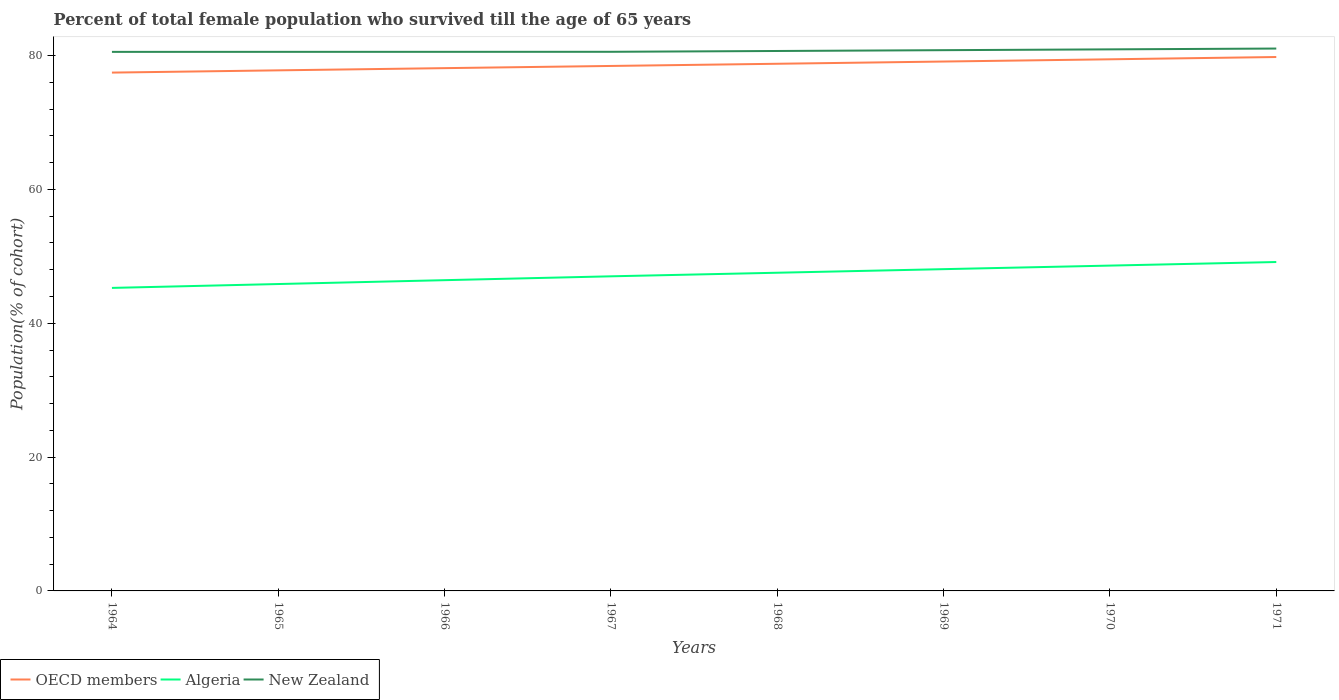Does the line corresponding to Algeria intersect with the line corresponding to OECD members?
Ensure brevity in your answer.  No. Is the number of lines equal to the number of legend labels?
Ensure brevity in your answer.  Yes. Across all years, what is the maximum percentage of total female population who survived till the age of 65 years in OECD members?
Your response must be concise. 77.46. In which year was the percentage of total female population who survived till the age of 65 years in New Zealand maximum?
Your answer should be very brief. 1964. What is the total percentage of total female population who survived till the age of 65 years in OECD members in the graph?
Your answer should be very brief. -1.66. What is the difference between the highest and the second highest percentage of total female population who survived till the age of 65 years in New Zealand?
Ensure brevity in your answer.  0.5. What is the difference between two consecutive major ticks on the Y-axis?
Your answer should be very brief. 20. Does the graph contain any zero values?
Your response must be concise. No. Where does the legend appear in the graph?
Offer a very short reply. Bottom left. How many legend labels are there?
Offer a terse response. 3. What is the title of the graph?
Provide a succinct answer. Percent of total female population who survived till the age of 65 years. Does "Germany" appear as one of the legend labels in the graph?
Ensure brevity in your answer.  No. What is the label or title of the Y-axis?
Offer a very short reply. Population(% of cohort). What is the Population(% of cohort) in OECD members in 1964?
Provide a succinct answer. 77.46. What is the Population(% of cohort) in Algeria in 1964?
Keep it short and to the point. 45.28. What is the Population(% of cohort) of New Zealand in 1964?
Give a very brief answer. 80.56. What is the Population(% of cohort) of OECD members in 1965?
Your answer should be very brief. 77.8. What is the Population(% of cohort) in Algeria in 1965?
Your answer should be compact. 45.86. What is the Population(% of cohort) of New Zealand in 1965?
Give a very brief answer. 80.56. What is the Population(% of cohort) in OECD members in 1966?
Provide a succinct answer. 78.13. What is the Population(% of cohort) in Algeria in 1966?
Offer a terse response. 46.44. What is the Population(% of cohort) in New Zealand in 1966?
Offer a very short reply. 80.56. What is the Population(% of cohort) of OECD members in 1967?
Keep it short and to the point. 78.45. What is the Population(% of cohort) of Algeria in 1967?
Your answer should be compact. 47.01. What is the Population(% of cohort) of New Zealand in 1967?
Your answer should be compact. 80.57. What is the Population(% of cohort) of OECD members in 1968?
Offer a very short reply. 78.78. What is the Population(% of cohort) in Algeria in 1968?
Make the answer very short. 47.55. What is the Population(% of cohort) of New Zealand in 1968?
Ensure brevity in your answer.  80.69. What is the Population(% of cohort) of OECD members in 1969?
Keep it short and to the point. 79.11. What is the Population(% of cohort) in Algeria in 1969?
Give a very brief answer. 48.08. What is the Population(% of cohort) in New Zealand in 1969?
Your answer should be compact. 80.81. What is the Population(% of cohort) in OECD members in 1970?
Your answer should be compact. 79.45. What is the Population(% of cohort) in Algeria in 1970?
Offer a terse response. 48.62. What is the Population(% of cohort) in New Zealand in 1970?
Keep it short and to the point. 80.93. What is the Population(% of cohort) of OECD members in 1971?
Provide a short and direct response. 79.79. What is the Population(% of cohort) of Algeria in 1971?
Your response must be concise. 49.15. What is the Population(% of cohort) of New Zealand in 1971?
Provide a succinct answer. 81.05. Across all years, what is the maximum Population(% of cohort) in OECD members?
Your response must be concise. 79.79. Across all years, what is the maximum Population(% of cohort) in Algeria?
Give a very brief answer. 49.15. Across all years, what is the maximum Population(% of cohort) in New Zealand?
Make the answer very short. 81.05. Across all years, what is the minimum Population(% of cohort) of OECD members?
Your answer should be compact. 77.46. Across all years, what is the minimum Population(% of cohort) in Algeria?
Provide a short and direct response. 45.28. Across all years, what is the minimum Population(% of cohort) in New Zealand?
Your answer should be very brief. 80.56. What is the total Population(% of cohort) in OECD members in the graph?
Provide a succinct answer. 628.96. What is the total Population(% of cohort) in Algeria in the graph?
Make the answer very short. 378. What is the total Population(% of cohort) of New Zealand in the graph?
Keep it short and to the point. 645.73. What is the difference between the Population(% of cohort) in OECD members in 1964 and that in 1965?
Your answer should be very brief. -0.34. What is the difference between the Population(% of cohort) of Algeria in 1964 and that in 1965?
Your answer should be very brief. -0.58. What is the difference between the Population(% of cohort) in New Zealand in 1964 and that in 1965?
Your answer should be very brief. -0. What is the difference between the Population(% of cohort) of OECD members in 1964 and that in 1966?
Keep it short and to the point. -0.67. What is the difference between the Population(% of cohort) in Algeria in 1964 and that in 1966?
Offer a terse response. -1.15. What is the difference between the Population(% of cohort) of New Zealand in 1964 and that in 1966?
Give a very brief answer. -0.01. What is the difference between the Population(% of cohort) in OECD members in 1964 and that in 1967?
Make the answer very short. -0.99. What is the difference between the Population(% of cohort) of Algeria in 1964 and that in 1967?
Give a very brief answer. -1.73. What is the difference between the Population(% of cohort) in New Zealand in 1964 and that in 1967?
Keep it short and to the point. -0.01. What is the difference between the Population(% of cohort) of OECD members in 1964 and that in 1968?
Ensure brevity in your answer.  -1.32. What is the difference between the Population(% of cohort) of Algeria in 1964 and that in 1968?
Offer a terse response. -2.27. What is the difference between the Population(% of cohort) in New Zealand in 1964 and that in 1968?
Keep it short and to the point. -0.13. What is the difference between the Population(% of cohort) of OECD members in 1964 and that in 1969?
Keep it short and to the point. -1.65. What is the difference between the Population(% of cohort) in Algeria in 1964 and that in 1969?
Provide a short and direct response. -2.8. What is the difference between the Population(% of cohort) of New Zealand in 1964 and that in 1969?
Provide a succinct answer. -0.25. What is the difference between the Population(% of cohort) in OECD members in 1964 and that in 1970?
Offer a very short reply. -1.99. What is the difference between the Population(% of cohort) of Algeria in 1964 and that in 1970?
Provide a succinct answer. -3.33. What is the difference between the Population(% of cohort) of New Zealand in 1964 and that in 1970?
Offer a terse response. -0.38. What is the difference between the Population(% of cohort) of OECD members in 1964 and that in 1971?
Keep it short and to the point. -2.33. What is the difference between the Population(% of cohort) of Algeria in 1964 and that in 1971?
Provide a succinct answer. -3.87. What is the difference between the Population(% of cohort) of New Zealand in 1964 and that in 1971?
Give a very brief answer. -0.5. What is the difference between the Population(% of cohort) of OECD members in 1965 and that in 1966?
Offer a terse response. -0.33. What is the difference between the Population(% of cohort) in Algeria in 1965 and that in 1966?
Your answer should be compact. -0.58. What is the difference between the Population(% of cohort) of New Zealand in 1965 and that in 1966?
Your answer should be compact. -0. What is the difference between the Population(% of cohort) of OECD members in 1965 and that in 1967?
Your answer should be compact. -0.66. What is the difference between the Population(% of cohort) of Algeria in 1965 and that in 1967?
Your answer should be compact. -1.15. What is the difference between the Population(% of cohort) of New Zealand in 1965 and that in 1967?
Your answer should be very brief. -0.01. What is the difference between the Population(% of cohort) in OECD members in 1965 and that in 1968?
Offer a very short reply. -0.98. What is the difference between the Population(% of cohort) in Algeria in 1965 and that in 1968?
Provide a short and direct response. -1.69. What is the difference between the Population(% of cohort) in New Zealand in 1965 and that in 1968?
Provide a succinct answer. -0.13. What is the difference between the Population(% of cohort) of OECD members in 1965 and that in 1969?
Make the answer very short. -1.32. What is the difference between the Population(% of cohort) of Algeria in 1965 and that in 1969?
Provide a short and direct response. -2.22. What is the difference between the Population(% of cohort) of New Zealand in 1965 and that in 1969?
Offer a very short reply. -0.25. What is the difference between the Population(% of cohort) in OECD members in 1965 and that in 1970?
Provide a short and direct response. -1.65. What is the difference between the Population(% of cohort) in Algeria in 1965 and that in 1970?
Give a very brief answer. -2.76. What is the difference between the Population(% of cohort) in New Zealand in 1965 and that in 1970?
Provide a short and direct response. -0.37. What is the difference between the Population(% of cohort) in OECD members in 1965 and that in 1971?
Your response must be concise. -1.99. What is the difference between the Population(% of cohort) in Algeria in 1965 and that in 1971?
Your answer should be compact. -3.29. What is the difference between the Population(% of cohort) in New Zealand in 1965 and that in 1971?
Keep it short and to the point. -0.49. What is the difference between the Population(% of cohort) of OECD members in 1966 and that in 1967?
Your response must be concise. -0.33. What is the difference between the Population(% of cohort) in Algeria in 1966 and that in 1967?
Offer a terse response. -0.58. What is the difference between the Population(% of cohort) of New Zealand in 1966 and that in 1967?
Your answer should be compact. -0. What is the difference between the Population(% of cohort) of OECD members in 1966 and that in 1968?
Your response must be concise. -0.65. What is the difference between the Population(% of cohort) of Algeria in 1966 and that in 1968?
Give a very brief answer. -1.11. What is the difference between the Population(% of cohort) in New Zealand in 1966 and that in 1968?
Your answer should be compact. -0.13. What is the difference between the Population(% of cohort) in OECD members in 1966 and that in 1969?
Make the answer very short. -0.99. What is the difference between the Population(% of cohort) in Algeria in 1966 and that in 1969?
Your answer should be compact. -1.65. What is the difference between the Population(% of cohort) in New Zealand in 1966 and that in 1969?
Your answer should be very brief. -0.25. What is the difference between the Population(% of cohort) of OECD members in 1966 and that in 1970?
Your response must be concise. -1.32. What is the difference between the Population(% of cohort) in Algeria in 1966 and that in 1970?
Ensure brevity in your answer.  -2.18. What is the difference between the Population(% of cohort) of New Zealand in 1966 and that in 1970?
Your answer should be very brief. -0.37. What is the difference between the Population(% of cohort) of OECD members in 1966 and that in 1971?
Ensure brevity in your answer.  -1.66. What is the difference between the Population(% of cohort) of Algeria in 1966 and that in 1971?
Offer a very short reply. -2.71. What is the difference between the Population(% of cohort) of New Zealand in 1966 and that in 1971?
Your answer should be very brief. -0.49. What is the difference between the Population(% of cohort) of OECD members in 1967 and that in 1968?
Give a very brief answer. -0.33. What is the difference between the Population(% of cohort) in Algeria in 1967 and that in 1968?
Your response must be concise. -0.53. What is the difference between the Population(% of cohort) in New Zealand in 1967 and that in 1968?
Your answer should be compact. -0.12. What is the difference between the Population(% of cohort) of OECD members in 1967 and that in 1969?
Provide a short and direct response. -0.66. What is the difference between the Population(% of cohort) in Algeria in 1967 and that in 1969?
Your answer should be very brief. -1.07. What is the difference between the Population(% of cohort) of New Zealand in 1967 and that in 1969?
Give a very brief answer. -0.24. What is the difference between the Population(% of cohort) of OECD members in 1967 and that in 1970?
Ensure brevity in your answer.  -0.99. What is the difference between the Population(% of cohort) of Algeria in 1967 and that in 1970?
Your response must be concise. -1.6. What is the difference between the Population(% of cohort) in New Zealand in 1967 and that in 1970?
Make the answer very short. -0.37. What is the difference between the Population(% of cohort) of OECD members in 1967 and that in 1971?
Offer a terse response. -1.33. What is the difference between the Population(% of cohort) of Algeria in 1967 and that in 1971?
Your answer should be very brief. -2.14. What is the difference between the Population(% of cohort) of New Zealand in 1967 and that in 1971?
Your response must be concise. -0.49. What is the difference between the Population(% of cohort) in OECD members in 1968 and that in 1969?
Make the answer very short. -0.33. What is the difference between the Population(% of cohort) of Algeria in 1968 and that in 1969?
Ensure brevity in your answer.  -0.53. What is the difference between the Population(% of cohort) of New Zealand in 1968 and that in 1969?
Give a very brief answer. -0.12. What is the difference between the Population(% of cohort) in OECD members in 1968 and that in 1970?
Provide a succinct answer. -0.67. What is the difference between the Population(% of cohort) in Algeria in 1968 and that in 1970?
Ensure brevity in your answer.  -1.07. What is the difference between the Population(% of cohort) of New Zealand in 1968 and that in 1970?
Your answer should be compact. -0.24. What is the difference between the Population(% of cohort) in OECD members in 1968 and that in 1971?
Keep it short and to the point. -1.01. What is the difference between the Population(% of cohort) in Algeria in 1968 and that in 1971?
Provide a succinct answer. -1.6. What is the difference between the Population(% of cohort) in New Zealand in 1968 and that in 1971?
Your answer should be compact. -0.37. What is the difference between the Population(% of cohort) in OECD members in 1969 and that in 1970?
Provide a short and direct response. -0.33. What is the difference between the Population(% of cohort) of Algeria in 1969 and that in 1970?
Make the answer very short. -0.53. What is the difference between the Population(% of cohort) in New Zealand in 1969 and that in 1970?
Give a very brief answer. -0.12. What is the difference between the Population(% of cohort) of OECD members in 1969 and that in 1971?
Offer a terse response. -0.67. What is the difference between the Population(% of cohort) in Algeria in 1969 and that in 1971?
Your response must be concise. -1.07. What is the difference between the Population(% of cohort) in New Zealand in 1969 and that in 1971?
Provide a succinct answer. -0.24. What is the difference between the Population(% of cohort) in OECD members in 1970 and that in 1971?
Give a very brief answer. -0.34. What is the difference between the Population(% of cohort) in Algeria in 1970 and that in 1971?
Make the answer very short. -0.53. What is the difference between the Population(% of cohort) in New Zealand in 1970 and that in 1971?
Keep it short and to the point. -0.12. What is the difference between the Population(% of cohort) in OECD members in 1964 and the Population(% of cohort) in Algeria in 1965?
Offer a very short reply. 31.6. What is the difference between the Population(% of cohort) of OECD members in 1964 and the Population(% of cohort) of New Zealand in 1965?
Keep it short and to the point. -3.1. What is the difference between the Population(% of cohort) in Algeria in 1964 and the Population(% of cohort) in New Zealand in 1965?
Offer a very short reply. -35.28. What is the difference between the Population(% of cohort) of OECD members in 1964 and the Population(% of cohort) of Algeria in 1966?
Give a very brief answer. 31.02. What is the difference between the Population(% of cohort) of OECD members in 1964 and the Population(% of cohort) of New Zealand in 1966?
Your answer should be compact. -3.1. What is the difference between the Population(% of cohort) of Algeria in 1964 and the Population(% of cohort) of New Zealand in 1966?
Provide a short and direct response. -35.28. What is the difference between the Population(% of cohort) in OECD members in 1964 and the Population(% of cohort) in Algeria in 1967?
Your answer should be compact. 30.44. What is the difference between the Population(% of cohort) of OECD members in 1964 and the Population(% of cohort) of New Zealand in 1967?
Provide a succinct answer. -3.11. What is the difference between the Population(% of cohort) of Algeria in 1964 and the Population(% of cohort) of New Zealand in 1967?
Make the answer very short. -35.28. What is the difference between the Population(% of cohort) in OECD members in 1964 and the Population(% of cohort) in Algeria in 1968?
Your response must be concise. 29.91. What is the difference between the Population(% of cohort) in OECD members in 1964 and the Population(% of cohort) in New Zealand in 1968?
Your answer should be compact. -3.23. What is the difference between the Population(% of cohort) of Algeria in 1964 and the Population(% of cohort) of New Zealand in 1968?
Your response must be concise. -35.4. What is the difference between the Population(% of cohort) of OECD members in 1964 and the Population(% of cohort) of Algeria in 1969?
Offer a very short reply. 29.37. What is the difference between the Population(% of cohort) of OECD members in 1964 and the Population(% of cohort) of New Zealand in 1969?
Offer a very short reply. -3.35. What is the difference between the Population(% of cohort) of Algeria in 1964 and the Population(% of cohort) of New Zealand in 1969?
Ensure brevity in your answer.  -35.53. What is the difference between the Population(% of cohort) in OECD members in 1964 and the Population(% of cohort) in Algeria in 1970?
Keep it short and to the point. 28.84. What is the difference between the Population(% of cohort) in OECD members in 1964 and the Population(% of cohort) in New Zealand in 1970?
Keep it short and to the point. -3.47. What is the difference between the Population(% of cohort) of Algeria in 1964 and the Population(% of cohort) of New Zealand in 1970?
Offer a terse response. -35.65. What is the difference between the Population(% of cohort) of OECD members in 1964 and the Population(% of cohort) of Algeria in 1971?
Keep it short and to the point. 28.31. What is the difference between the Population(% of cohort) of OECD members in 1964 and the Population(% of cohort) of New Zealand in 1971?
Provide a short and direct response. -3.6. What is the difference between the Population(% of cohort) of Algeria in 1964 and the Population(% of cohort) of New Zealand in 1971?
Your answer should be very brief. -35.77. What is the difference between the Population(% of cohort) in OECD members in 1965 and the Population(% of cohort) in Algeria in 1966?
Your response must be concise. 31.36. What is the difference between the Population(% of cohort) of OECD members in 1965 and the Population(% of cohort) of New Zealand in 1966?
Provide a succinct answer. -2.77. What is the difference between the Population(% of cohort) of Algeria in 1965 and the Population(% of cohort) of New Zealand in 1966?
Provide a succinct answer. -34.7. What is the difference between the Population(% of cohort) in OECD members in 1965 and the Population(% of cohort) in Algeria in 1967?
Your answer should be very brief. 30.78. What is the difference between the Population(% of cohort) of OECD members in 1965 and the Population(% of cohort) of New Zealand in 1967?
Keep it short and to the point. -2.77. What is the difference between the Population(% of cohort) of Algeria in 1965 and the Population(% of cohort) of New Zealand in 1967?
Offer a very short reply. -34.71. What is the difference between the Population(% of cohort) in OECD members in 1965 and the Population(% of cohort) in Algeria in 1968?
Make the answer very short. 30.25. What is the difference between the Population(% of cohort) in OECD members in 1965 and the Population(% of cohort) in New Zealand in 1968?
Keep it short and to the point. -2.89. What is the difference between the Population(% of cohort) in Algeria in 1965 and the Population(% of cohort) in New Zealand in 1968?
Make the answer very short. -34.83. What is the difference between the Population(% of cohort) in OECD members in 1965 and the Population(% of cohort) in Algeria in 1969?
Your answer should be compact. 29.71. What is the difference between the Population(% of cohort) in OECD members in 1965 and the Population(% of cohort) in New Zealand in 1969?
Give a very brief answer. -3.01. What is the difference between the Population(% of cohort) of Algeria in 1965 and the Population(% of cohort) of New Zealand in 1969?
Ensure brevity in your answer.  -34.95. What is the difference between the Population(% of cohort) in OECD members in 1965 and the Population(% of cohort) in Algeria in 1970?
Give a very brief answer. 29.18. What is the difference between the Population(% of cohort) in OECD members in 1965 and the Population(% of cohort) in New Zealand in 1970?
Offer a very short reply. -3.14. What is the difference between the Population(% of cohort) of Algeria in 1965 and the Population(% of cohort) of New Zealand in 1970?
Provide a succinct answer. -35.07. What is the difference between the Population(% of cohort) in OECD members in 1965 and the Population(% of cohort) in Algeria in 1971?
Give a very brief answer. 28.64. What is the difference between the Population(% of cohort) in OECD members in 1965 and the Population(% of cohort) in New Zealand in 1971?
Make the answer very short. -3.26. What is the difference between the Population(% of cohort) in Algeria in 1965 and the Population(% of cohort) in New Zealand in 1971?
Your answer should be very brief. -35.19. What is the difference between the Population(% of cohort) of OECD members in 1966 and the Population(% of cohort) of Algeria in 1967?
Your response must be concise. 31.11. What is the difference between the Population(% of cohort) in OECD members in 1966 and the Population(% of cohort) in New Zealand in 1967?
Keep it short and to the point. -2.44. What is the difference between the Population(% of cohort) in Algeria in 1966 and the Population(% of cohort) in New Zealand in 1967?
Offer a terse response. -34.13. What is the difference between the Population(% of cohort) of OECD members in 1966 and the Population(% of cohort) of Algeria in 1968?
Give a very brief answer. 30.58. What is the difference between the Population(% of cohort) of OECD members in 1966 and the Population(% of cohort) of New Zealand in 1968?
Offer a very short reply. -2.56. What is the difference between the Population(% of cohort) of Algeria in 1966 and the Population(% of cohort) of New Zealand in 1968?
Your answer should be compact. -34.25. What is the difference between the Population(% of cohort) in OECD members in 1966 and the Population(% of cohort) in Algeria in 1969?
Keep it short and to the point. 30.04. What is the difference between the Population(% of cohort) in OECD members in 1966 and the Population(% of cohort) in New Zealand in 1969?
Your response must be concise. -2.68. What is the difference between the Population(% of cohort) of Algeria in 1966 and the Population(% of cohort) of New Zealand in 1969?
Offer a terse response. -34.37. What is the difference between the Population(% of cohort) in OECD members in 1966 and the Population(% of cohort) in Algeria in 1970?
Provide a succinct answer. 29.51. What is the difference between the Population(% of cohort) in OECD members in 1966 and the Population(% of cohort) in New Zealand in 1970?
Offer a terse response. -2.81. What is the difference between the Population(% of cohort) in Algeria in 1966 and the Population(% of cohort) in New Zealand in 1970?
Offer a terse response. -34.49. What is the difference between the Population(% of cohort) in OECD members in 1966 and the Population(% of cohort) in Algeria in 1971?
Provide a succinct answer. 28.97. What is the difference between the Population(% of cohort) in OECD members in 1966 and the Population(% of cohort) in New Zealand in 1971?
Your answer should be very brief. -2.93. What is the difference between the Population(% of cohort) of Algeria in 1966 and the Population(% of cohort) of New Zealand in 1971?
Provide a short and direct response. -34.62. What is the difference between the Population(% of cohort) in OECD members in 1967 and the Population(% of cohort) in Algeria in 1968?
Your answer should be very brief. 30.9. What is the difference between the Population(% of cohort) of OECD members in 1967 and the Population(% of cohort) of New Zealand in 1968?
Ensure brevity in your answer.  -2.24. What is the difference between the Population(% of cohort) in Algeria in 1967 and the Population(% of cohort) in New Zealand in 1968?
Provide a short and direct response. -33.67. What is the difference between the Population(% of cohort) in OECD members in 1967 and the Population(% of cohort) in Algeria in 1969?
Provide a short and direct response. 30.37. What is the difference between the Population(% of cohort) in OECD members in 1967 and the Population(% of cohort) in New Zealand in 1969?
Provide a succinct answer. -2.36. What is the difference between the Population(% of cohort) of Algeria in 1967 and the Population(% of cohort) of New Zealand in 1969?
Your answer should be very brief. -33.8. What is the difference between the Population(% of cohort) in OECD members in 1967 and the Population(% of cohort) in Algeria in 1970?
Give a very brief answer. 29.83. What is the difference between the Population(% of cohort) in OECD members in 1967 and the Population(% of cohort) in New Zealand in 1970?
Ensure brevity in your answer.  -2.48. What is the difference between the Population(% of cohort) in Algeria in 1967 and the Population(% of cohort) in New Zealand in 1970?
Offer a very short reply. -33.92. What is the difference between the Population(% of cohort) of OECD members in 1967 and the Population(% of cohort) of Algeria in 1971?
Give a very brief answer. 29.3. What is the difference between the Population(% of cohort) of OECD members in 1967 and the Population(% of cohort) of New Zealand in 1971?
Give a very brief answer. -2.6. What is the difference between the Population(% of cohort) in Algeria in 1967 and the Population(% of cohort) in New Zealand in 1971?
Keep it short and to the point. -34.04. What is the difference between the Population(% of cohort) in OECD members in 1968 and the Population(% of cohort) in Algeria in 1969?
Provide a succinct answer. 30.69. What is the difference between the Population(% of cohort) of OECD members in 1968 and the Population(% of cohort) of New Zealand in 1969?
Your answer should be compact. -2.03. What is the difference between the Population(% of cohort) in Algeria in 1968 and the Population(% of cohort) in New Zealand in 1969?
Your response must be concise. -33.26. What is the difference between the Population(% of cohort) in OECD members in 1968 and the Population(% of cohort) in Algeria in 1970?
Give a very brief answer. 30.16. What is the difference between the Population(% of cohort) in OECD members in 1968 and the Population(% of cohort) in New Zealand in 1970?
Give a very brief answer. -2.15. What is the difference between the Population(% of cohort) of Algeria in 1968 and the Population(% of cohort) of New Zealand in 1970?
Your answer should be compact. -33.38. What is the difference between the Population(% of cohort) of OECD members in 1968 and the Population(% of cohort) of Algeria in 1971?
Make the answer very short. 29.63. What is the difference between the Population(% of cohort) of OECD members in 1968 and the Population(% of cohort) of New Zealand in 1971?
Offer a very short reply. -2.28. What is the difference between the Population(% of cohort) of Algeria in 1968 and the Population(% of cohort) of New Zealand in 1971?
Provide a succinct answer. -33.5. What is the difference between the Population(% of cohort) of OECD members in 1969 and the Population(% of cohort) of Algeria in 1970?
Provide a succinct answer. 30.49. What is the difference between the Population(% of cohort) in OECD members in 1969 and the Population(% of cohort) in New Zealand in 1970?
Provide a short and direct response. -1.82. What is the difference between the Population(% of cohort) of Algeria in 1969 and the Population(% of cohort) of New Zealand in 1970?
Make the answer very short. -32.85. What is the difference between the Population(% of cohort) of OECD members in 1969 and the Population(% of cohort) of Algeria in 1971?
Your answer should be very brief. 29.96. What is the difference between the Population(% of cohort) in OECD members in 1969 and the Population(% of cohort) in New Zealand in 1971?
Offer a very short reply. -1.94. What is the difference between the Population(% of cohort) in Algeria in 1969 and the Population(% of cohort) in New Zealand in 1971?
Offer a very short reply. -32.97. What is the difference between the Population(% of cohort) of OECD members in 1970 and the Population(% of cohort) of Algeria in 1971?
Make the answer very short. 30.29. What is the difference between the Population(% of cohort) in OECD members in 1970 and the Population(% of cohort) in New Zealand in 1971?
Provide a short and direct response. -1.61. What is the difference between the Population(% of cohort) in Algeria in 1970 and the Population(% of cohort) in New Zealand in 1971?
Your answer should be compact. -32.44. What is the average Population(% of cohort) of OECD members per year?
Provide a succinct answer. 78.62. What is the average Population(% of cohort) of Algeria per year?
Keep it short and to the point. 47.25. What is the average Population(% of cohort) of New Zealand per year?
Offer a very short reply. 80.72. In the year 1964, what is the difference between the Population(% of cohort) of OECD members and Population(% of cohort) of Algeria?
Give a very brief answer. 32.17. In the year 1964, what is the difference between the Population(% of cohort) of OECD members and Population(% of cohort) of New Zealand?
Your answer should be compact. -3.1. In the year 1964, what is the difference between the Population(% of cohort) of Algeria and Population(% of cohort) of New Zealand?
Provide a short and direct response. -35.27. In the year 1965, what is the difference between the Population(% of cohort) of OECD members and Population(% of cohort) of Algeria?
Offer a very short reply. 31.94. In the year 1965, what is the difference between the Population(% of cohort) of OECD members and Population(% of cohort) of New Zealand?
Offer a very short reply. -2.76. In the year 1965, what is the difference between the Population(% of cohort) of Algeria and Population(% of cohort) of New Zealand?
Keep it short and to the point. -34.7. In the year 1966, what is the difference between the Population(% of cohort) of OECD members and Population(% of cohort) of Algeria?
Provide a short and direct response. 31.69. In the year 1966, what is the difference between the Population(% of cohort) in OECD members and Population(% of cohort) in New Zealand?
Make the answer very short. -2.44. In the year 1966, what is the difference between the Population(% of cohort) of Algeria and Population(% of cohort) of New Zealand?
Give a very brief answer. -34.12. In the year 1967, what is the difference between the Population(% of cohort) of OECD members and Population(% of cohort) of Algeria?
Make the answer very short. 31.44. In the year 1967, what is the difference between the Population(% of cohort) of OECD members and Population(% of cohort) of New Zealand?
Keep it short and to the point. -2.11. In the year 1967, what is the difference between the Population(% of cohort) in Algeria and Population(% of cohort) in New Zealand?
Your answer should be very brief. -33.55. In the year 1968, what is the difference between the Population(% of cohort) of OECD members and Population(% of cohort) of Algeria?
Your answer should be compact. 31.23. In the year 1968, what is the difference between the Population(% of cohort) of OECD members and Population(% of cohort) of New Zealand?
Provide a succinct answer. -1.91. In the year 1968, what is the difference between the Population(% of cohort) of Algeria and Population(% of cohort) of New Zealand?
Give a very brief answer. -33.14. In the year 1969, what is the difference between the Population(% of cohort) of OECD members and Population(% of cohort) of Algeria?
Your response must be concise. 31.03. In the year 1969, what is the difference between the Population(% of cohort) in OECD members and Population(% of cohort) in New Zealand?
Make the answer very short. -1.7. In the year 1969, what is the difference between the Population(% of cohort) in Algeria and Population(% of cohort) in New Zealand?
Offer a very short reply. -32.73. In the year 1970, what is the difference between the Population(% of cohort) in OECD members and Population(% of cohort) in Algeria?
Provide a succinct answer. 30.83. In the year 1970, what is the difference between the Population(% of cohort) of OECD members and Population(% of cohort) of New Zealand?
Your response must be concise. -1.49. In the year 1970, what is the difference between the Population(% of cohort) in Algeria and Population(% of cohort) in New Zealand?
Offer a very short reply. -32.31. In the year 1971, what is the difference between the Population(% of cohort) of OECD members and Population(% of cohort) of Algeria?
Provide a succinct answer. 30.63. In the year 1971, what is the difference between the Population(% of cohort) of OECD members and Population(% of cohort) of New Zealand?
Ensure brevity in your answer.  -1.27. In the year 1971, what is the difference between the Population(% of cohort) of Algeria and Population(% of cohort) of New Zealand?
Offer a very short reply. -31.9. What is the ratio of the Population(% of cohort) of Algeria in 1964 to that in 1965?
Your response must be concise. 0.99. What is the ratio of the Population(% of cohort) in Algeria in 1964 to that in 1966?
Your answer should be very brief. 0.98. What is the ratio of the Population(% of cohort) in New Zealand in 1964 to that in 1966?
Keep it short and to the point. 1. What is the ratio of the Population(% of cohort) in OECD members in 1964 to that in 1967?
Your response must be concise. 0.99. What is the ratio of the Population(% of cohort) in Algeria in 1964 to that in 1967?
Your response must be concise. 0.96. What is the ratio of the Population(% of cohort) of OECD members in 1964 to that in 1968?
Offer a very short reply. 0.98. What is the ratio of the Population(% of cohort) of Algeria in 1964 to that in 1968?
Offer a terse response. 0.95. What is the ratio of the Population(% of cohort) of OECD members in 1964 to that in 1969?
Your answer should be very brief. 0.98. What is the ratio of the Population(% of cohort) in Algeria in 1964 to that in 1969?
Offer a very short reply. 0.94. What is the ratio of the Population(% of cohort) of New Zealand in 1964 to that in 1969?
Your response must be concise. 1. What is the ratio of the Population(% of cohort) of OECD members in 1964 to that in 1970?
Provide a short and direct response. 0.97. What is the ratio of the Population(% of cohort) of Algeria in 1964 to that in 1970?
Offer a terse response. 0.93. What is the ratio of the Population(% of cohort) of New Zealand in 1964 to that in 1970?
Ensure brevity in your answer.  1. What is the ratio of the Population(% of cohort) in OECD members in 1964 to that in 1971?
Offer a very short reply. 0.97. What is the ratio of the Population(% of cohort) of Algeria in 1964 to that in 1971?
Provide a succinct answer. 0.92. What is the ratio of the Population(% of cohort) in OECD members in 1965 to that in 1966?
Offer a terse response. 1. What is the ratio of the Population(% of cohort) in Algeria in 1965 to that in 1966?
Offer a terse response. 0.99. What is the ratio of the Population(% of cohort) of Algeria in 1965 to that in 1967?
Keep it short and to the point. 0.98. What is the ratio of the Population(% of cohort) of OECD members in 1965 to that in 1968?
Offer a very short reply. 0.99. What is the ratio of the Population(% of cohort) in Algeria in 1965 to that in 1968?
Your response must be concise. 0.96. What is the ratio of the Population(% of cohort) of OECD members in 1965 to that in 1969?
Offer a very short reply. 0.98. What is the ratio of the Population(% of cohort) in Algeria in 1965 to that in 1969?
Give a very brief answer. 0.95. What is the ratio of the Population(% of cohort) of OECD members in 1965 to that in 1970?
Your answer should be very brief. 0.98. What is the ratio of the Population(% of cohort) in Algeria in 1965 to that in 1970?
Ensure brevity in your answer.  0.94. What is the ratio of the Population(% of cohort) in New Zealand in 1965 to that in 1970?
Offer a terse response. 1. What is the ratio of the Population(% of cohort) in OECD members in 1965 to that in 1971?
Offer a terse response. 0.98. What is the ratio of the Population(% of cohort) of Algeria in 1965 to that in 1971?
Make the answer very short. 0.93. What is the ratio of the Population(% of cohort) of New Zealand in 1965 to that in 1971?
Give a very brief answer. 0.99. What is the ratio of the Population(% of cohort) of OECD members in 1966 to that in 1967?
Ensure brevity in your answer.  1. What is the ratio of the Population(% of cohort) of Algeria in 1966 to that in 1967?
Offer a very short reply. 0.99. What is the ratio of the Population(% of cohort) in New Zealand in 1966 to that in 1967?
Your response must be concise. 1. What is the ratio of the Population(% of cohort) in Algeria in 1966 to that in 1968?
Give a very brief answer. 0.98. What is the ratio of the Population(% of cohort) in OECD members in 1966 to that in 1969?
Provide a short and direct response. 0.99. What is the ratio of the Population(% of cohort) in Algeria in 1966 to that in 1969?
Offer a terse response. 0.97. What is the ratio of the Population(% of cohort) in OECD members in 1966 to that in 1970?
Provide a short and direct response. 0.98. What is the ratio of the Population(% of cohort) of Algeria in 1966 to that in 1970?
Make the answer very short. 0.96. What is the ratio of the Population(% of cohort) in New Zealand in 1966 to that in 1970?
Your answer should be compact. 1. What is the ratio of the Population(% of cohort) of OECD members in 1966 to that in 1971?
Your response must be concise. 0.98. What is the ratio of the Population(% of cohort) in Algeria in 1966 to that in 1971?
Make the answer very short. 0.94. What is the ratio of the Population(% of cohort) in New Zealand in 1966 to that in 1971?
Offer a terse response. 0.99. What is the ratio of the Population(% of cohort) in OECD members in 1967 to that in 1968?
Provide a short and direct response. 1. What is the ratio of the Population(% of cohort) in Algeria in 1967 to that in 1968?
Ensure brevity in your answer.  0.99. What is the ratio of the Population(% of cohort) in OECD members in 1967 to that in 1969?
Your answer should be compact. 0.99. What is the ratio of the Population(% of cohort) in Algeria in 1967 to that in 1969?
Provide a short and direct response. 0.98. What is the ratio of the Population(% of cohort) of OECD members in 1967 to that in 1970?
Make the answer very short. 0.99. What is the ratio of the Population(% of cohort) in OECD members in 1967 to that in 1971?
Provide a succinct answer. 0.98. What is the ratio of the Population(% of cohort) of Algeria in 1967 to that in 1971?
Provide a short and direct response. 0.96. What is the ratio of the Population(% of cohort) in New Zealand in 1967 to that in 1971?
Offer a terse response. 0.99. What is the ratio of the Population(% of cohort) of OECD members in 1968 to that in 1969?
Your answer should be compact. 1. What is the ratio of the Population(% of cohort) in Algeria in 1968 to that in 1969?
Your response must be concise. 0.99. What is the ratio of the Population(% of cohort) in OECD members in 1968 to that in 1970?
Provide a succinct answer. 0.99. What is the ratio of the Population(% of cohort) in New Zealand in 1968 to that in 1970?
Offer a very short reply. 1. What is the ratio of the Population(% of cohort) in OECD members in 1968 to that in 1971?
Provide a short and direct response. 0.99. What is the ratio of the Population(% of cohort) in Algeria in 1968 to that in 1971?
Give a very brief answer. 0.97. What is the ratio of the Population(% of cohort) in OECD members in 1969 to that in 1970?
Offer a very short reply. 1. What is the ratio of the Population(% of cohort) of Algeria in 1969 to that in 1971?
Ensure brevity in your answer.  0.98. What is the ratio of the Population(% of cohort) of Algeria in 1970 to that in 1971?
Provide a succinct answer. 0.99. What is the difference between the highest and the second highest Population(% of cohort) in OECD members?
Ensure brevity in your answer.  0.34. What is the difference between the highest and the second highest Population(% of cohort) of Algeria?
Give a very brief answer. 0.53. What is the difference between the highest and the second highest Population(% of cohort) of New Zealand?
Offer a terse response. 0.12. What is the difference between the highest and the lowest Population(% of cohort) in OECD members?
Your answer should be very brief. 2.33. What is the difference between the highest and the lowest Population(% of cohort) in Algeria?
Provide a succinct answer. 3.87. What is the difference between the highest and the lowest Population(% of cohort) in New Zealand?
Ensure brevity in your answer.  0.5. 